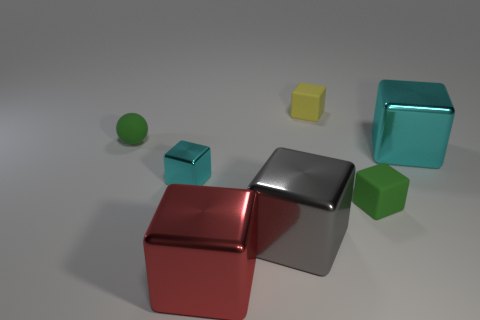How many objects are small matte objects that are in front of the large cyan metallic object or tiny matte blocks that are on the right side of the yellow matte block?
Your answer should be very brief. 1. What is the material of the cyan thing that is the same size as the gray metallic thing?
Your response must be concise. Metal. What color is the ball?
Give a very brief answer. Green. What is the material of the small object that is both on the right side of the tiny cyan metal object and behind the small cyan metal object?
Your response must be concise. Rubber. There is a thing that is behind the small green rubber object to the left of the gray object; is there a small yellow block that is right of it?
Provide a succinct answer. No. What is the size of the other metallic object that is the same color as the tiny metal object?
Your answer should be very brief. Large. Are there any tiny matte things on the left side of the small green matte sphere?
Your answer should be compact. No. How many other objects are there of the same shape as the big gray metal object?
Offer a terse response. 5. There is a metallic thing that is the same size as the green rubber sphere; what color is it?
Provide a succinct answer. Cyan. Are there fewer cyan objects that are left of the large cyan metal cube than large red shiny objects behind the tiny sphere?
Your answer should be compact. No. 